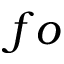<formula> <loc_0><loc_0><loc_500><loc_500>f o</formula> 